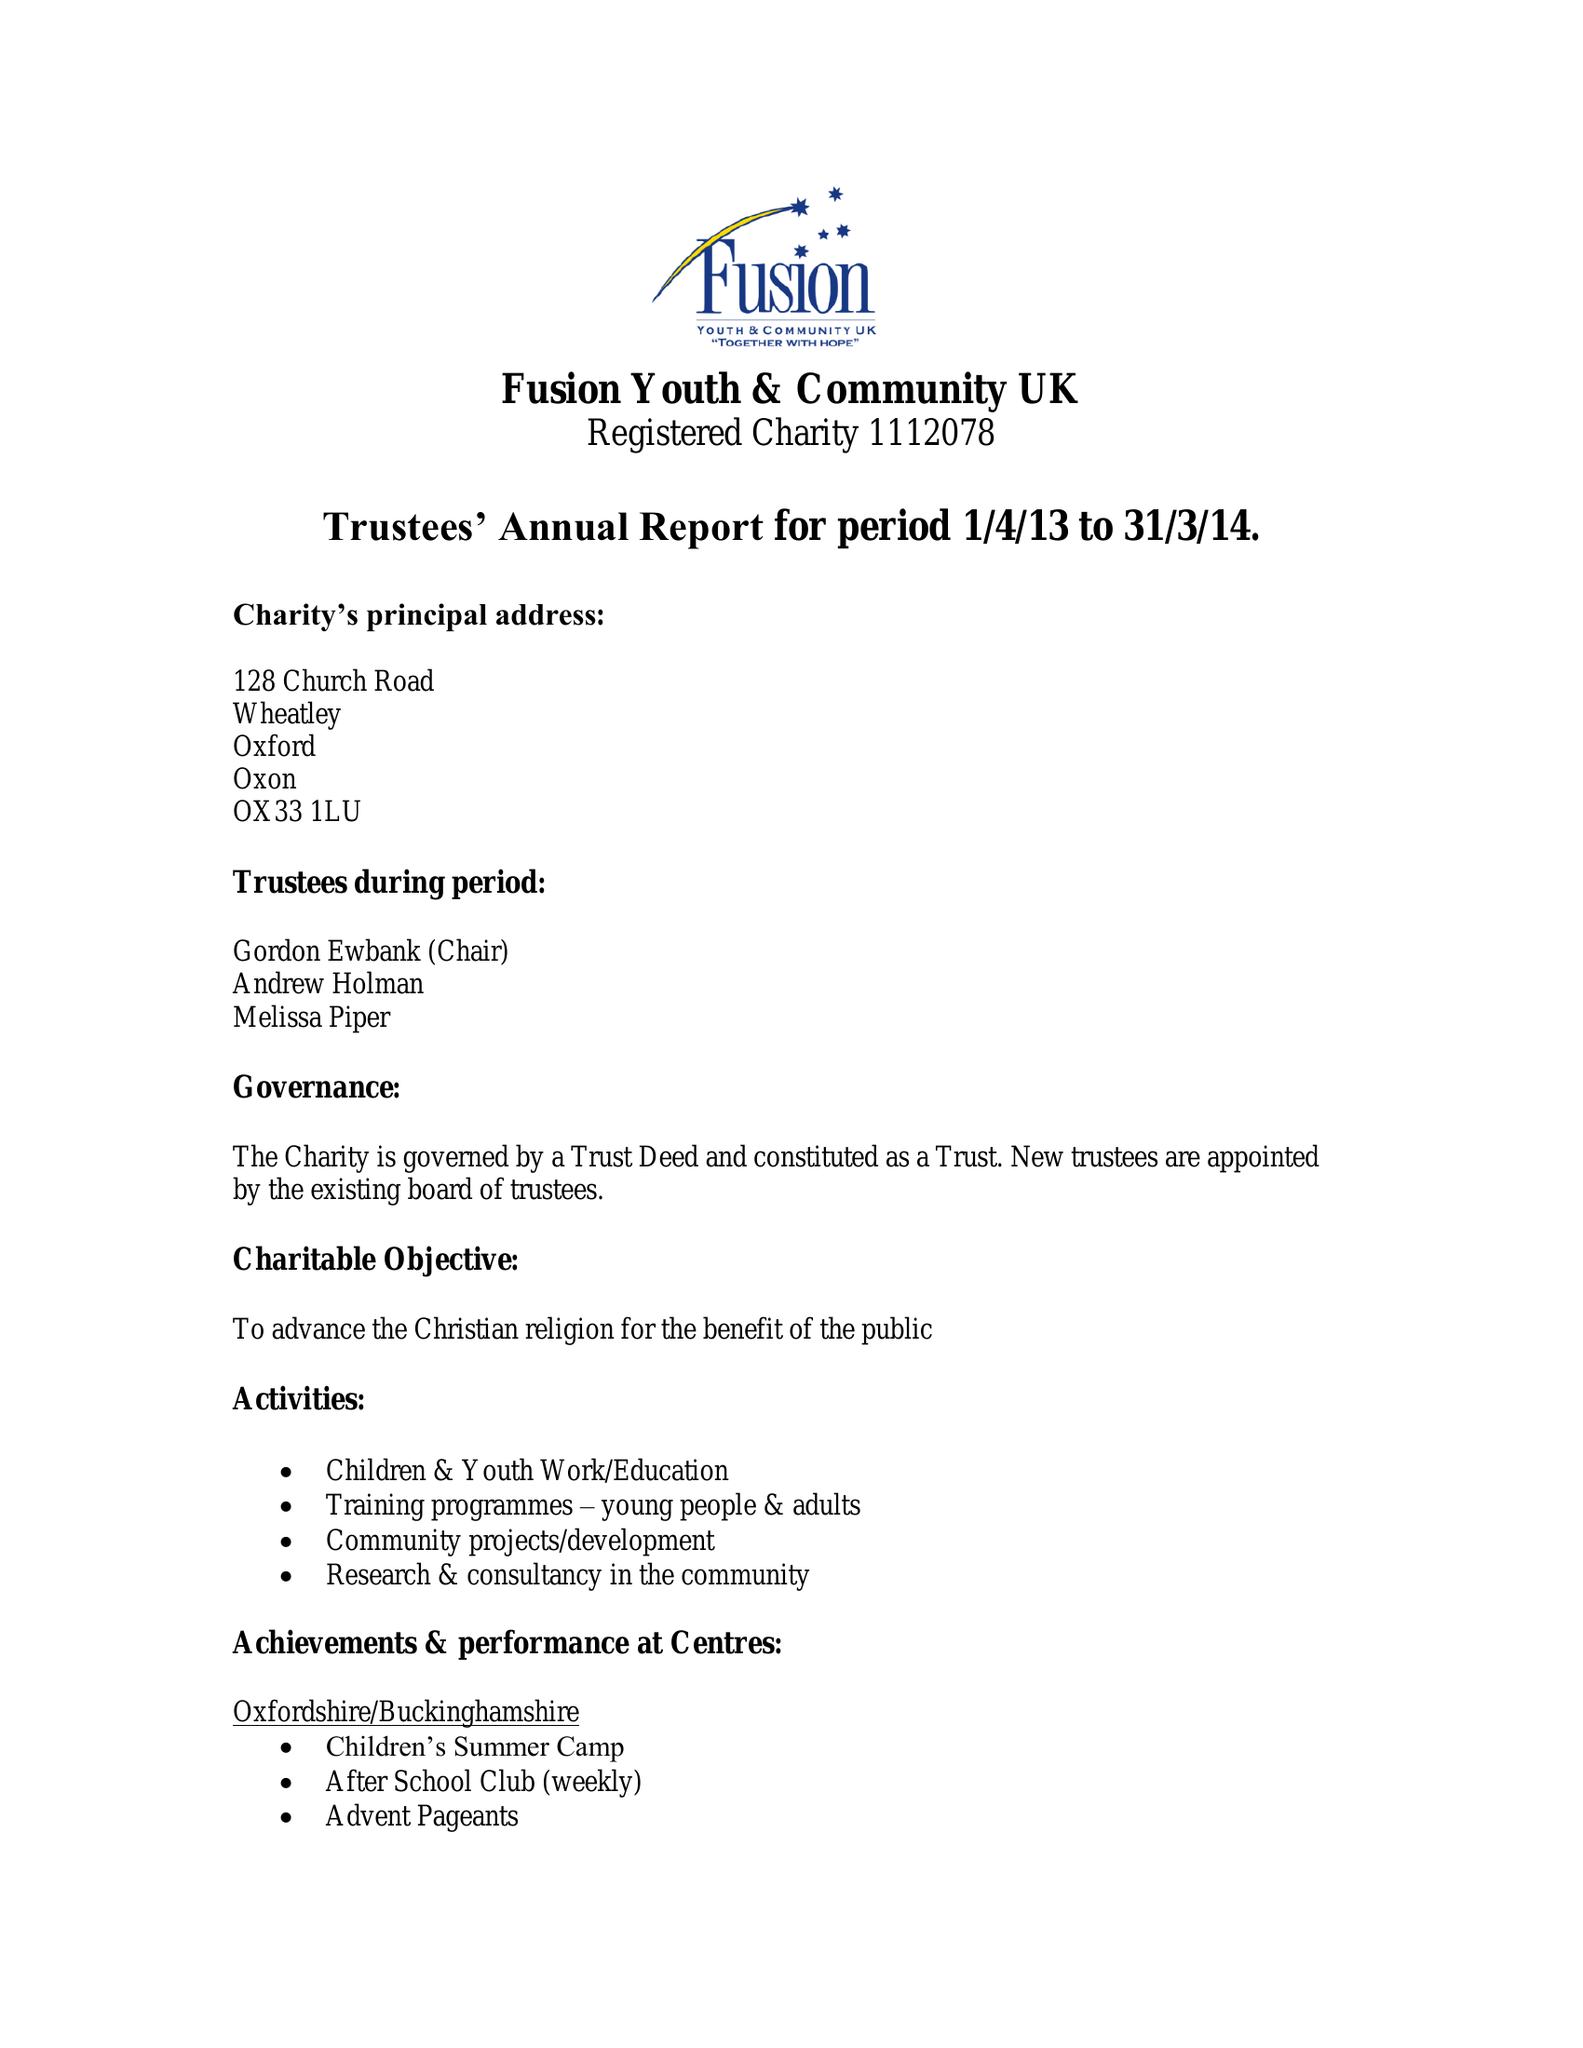What is the value for the charity_name?
Answer the question using a single word or phrase. Fusion Youth and Community Uk 